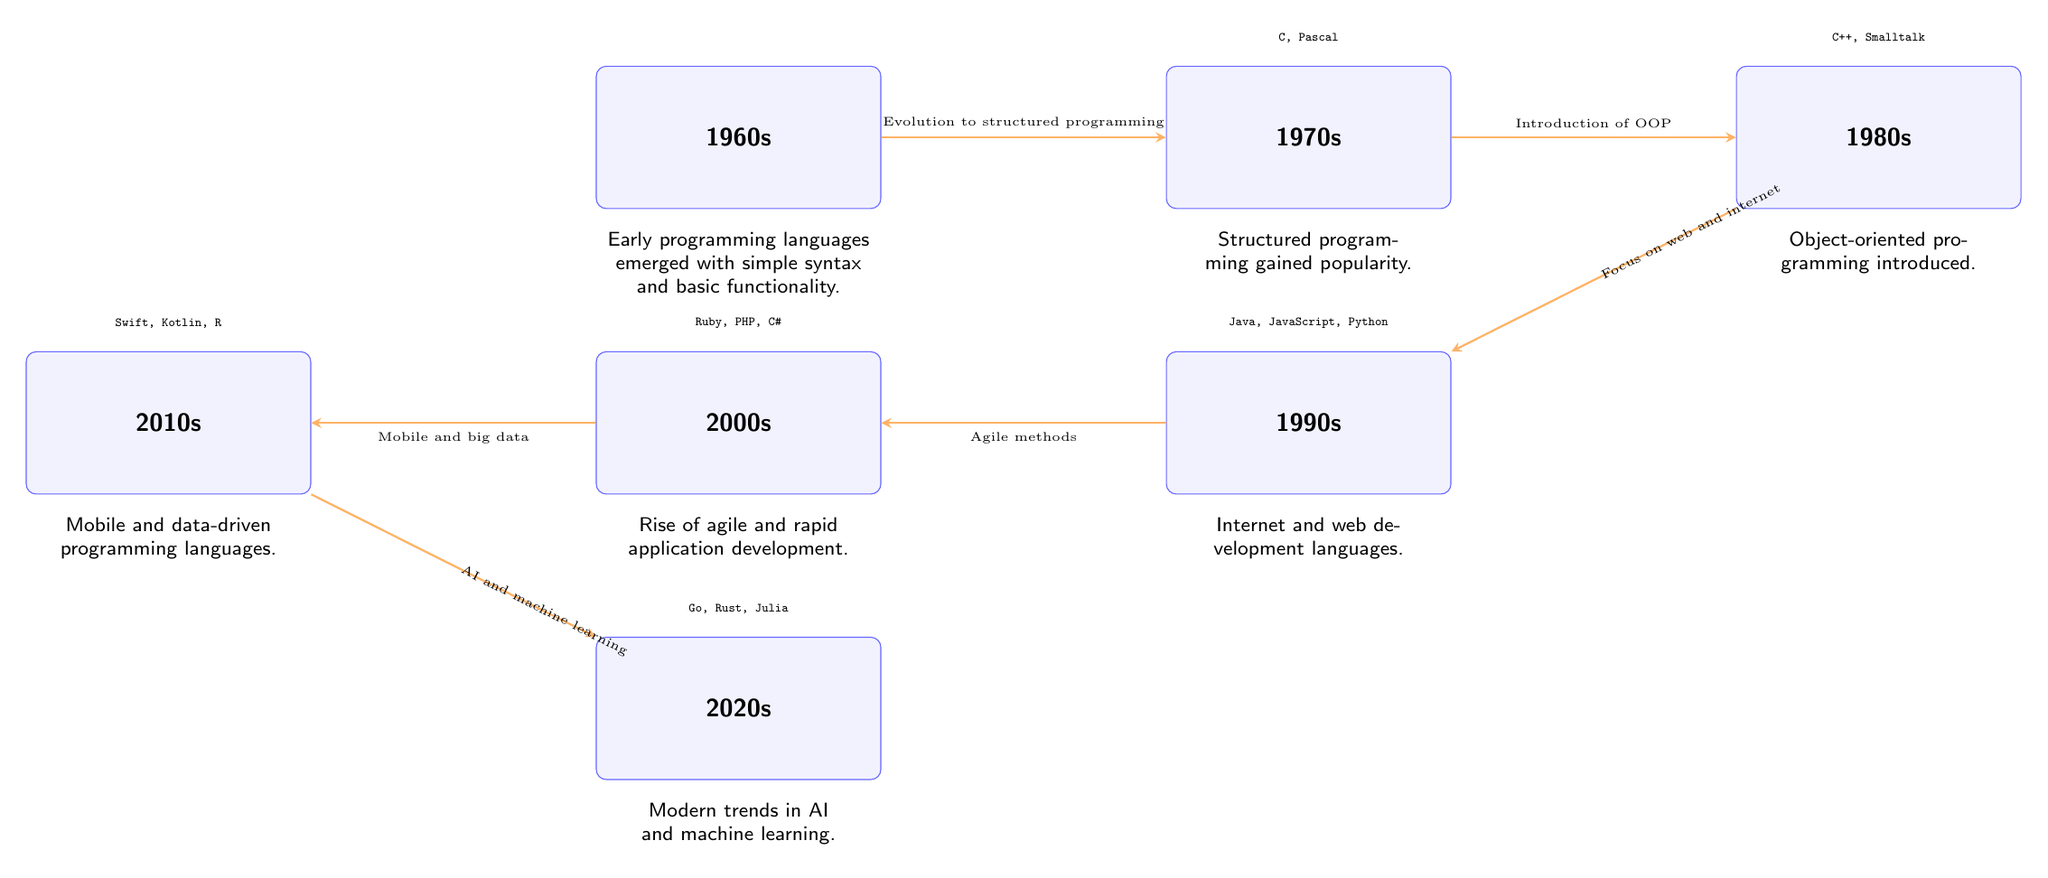What decade saw the introduction of object-oriented programming? The diagram identifies the 1980s as the decade where the introduction of object-oriented programming occurred, as indicated by the description node connected to the 1980s.
Answer: 1980s What languages are highlighted in the 1990s? The diagram lists Java, JavaScript, and Python as the key programming languages of the 1990s, positioned above the 1990s node.
Answer: Java, JavaScript, Python How many decades are shown in the diagram? By counting the decade nodes present in the diagram, there are six distinct decades: 1960s, 1970s, 1980s, 1990s, 2000s, 2010s, and 2020s.
Answer: Six What is the relationship between the 1990s and 2000s in terms of programming development? The edges connecting the 1990s and 2000s nodes highlight the transition from internet and web development languages to the rise of agile methods and rapid application development.
Answer: Agile methods Which programming languages emerged in the 2020s according to the diagram? The languages listed above the 2020s node are Go, Rust, and Julia, which represent the emerging trends in programming languages during that decade.
Answer: Go, Rust, Julia What major trend is highlighted in the 2010s? The description node below the 2010s indicates that mobile and data-driven programming languages were a major trend during this time period.
Answer: Mobile and data-driven programming languages What decade marks the rise of structured programming? The diagram points to the 1970s as the decade that saw structured programming gain popularity, as laid out in the description node beneath the 1970s.
Answer: 1970s Which development is identified as occurring after the introduction of object-oriented programming? The diagram shows that the development of web and internet languages emerged after the introduction of object-oriented programming in the 1980s, linked to the 1990s node.
Answer: Focus on web and internet 